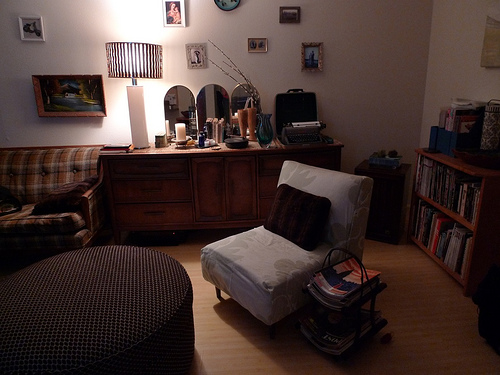<image>What shape is the rug? There is no rug in the image. However, it can be oval, round, or square. What shape is the rug? I don't know what shape the rug is. It can be oval, round, circle or square. 